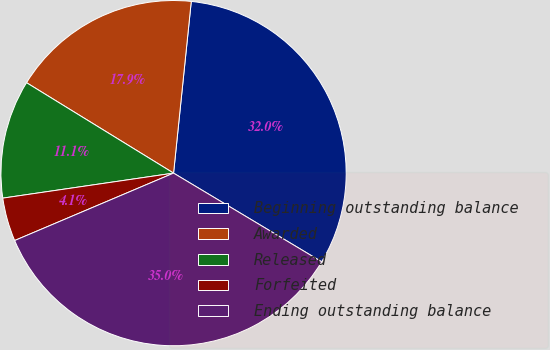Convert chart to OTSL. <chart><loc_0><loc_0><loc_500><loc_500><pie_chart><fcel>Beginning outstanding balance<fcel>Awarded<fcel>Released<fcel>Forfeited<fcel>Ending outstanding balance<nl><fcel>31.95%<fcel>17.86%<fcel>11.09%<fcel>4.07%<fcel>35.03%<nl></chart> 